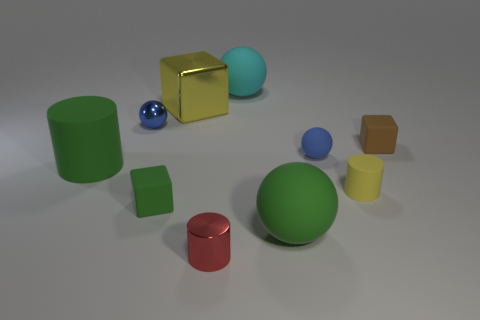What number of other objects are there of the same material as the green cylinder?
Your response must be concise. 6. Is the shape of the big rubber object behind the green matte cylinder the same as the tiny metallic object in front of the small brown object?
Keep it short and to the point. No. How many other things are the same color as the large rubber cylinder?
Offer a terse response. 2. Does the blue ball that is behind the blue rubber thing have the same material as the yellow thing that is behind the small yellow matte object?
Provide a short and direct response. Yes. Are there an equal number of blue things that are to the left of the green matte ball and rubber blocks in front of the tiny yellow rubber cylinder?
Make the answer very short. Yes. What material is the yellow thing that is behind the tiny yellow matte object?
Keep it short and to the point. Metal. Is the number of tiny red cylinders less than the number of tiny yellow metal objects?
Your response must be concise. No. What shape is the small thing that is left of the cyan thing and behind the yellow matte cylinder?
Keep it short and to the point. Sphere. How many gray blocks are there?
Keep it short and to the point. 0. What material is the blue ball in front of the cube to the right of the big ball that is behind the big metallic object made of?
Provide a succinct answer. Rubber. 